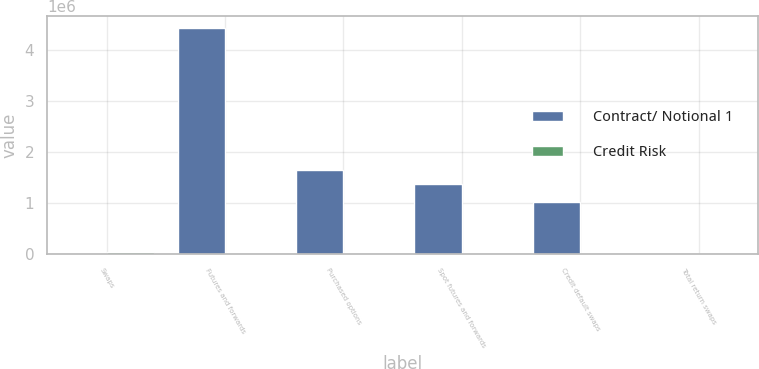Convert chart. <chart><loc_0><loc_0><loc_500><loc_500><stacked_bar_chart><ecel><fcel>Swaps<fcel>Futures and forwards<fcel>Purchased options<fcel>Spot futures and forwards<fcel>Credit default swaps<fcel>Total return swaps<nl><fcel>Contract/ Notional 1<fcel>11772<fcel>4.4321e+06<fcel>1.65664e+06<fcel>1.37648e+06<fcel>1.02588e+06<fcel>6575<nl><fcel>Credit Risk<fcel>48225<fcel>1008<fcel>5188<fcel>10888<fcel>11772<fcel>1678<nl></chart> 